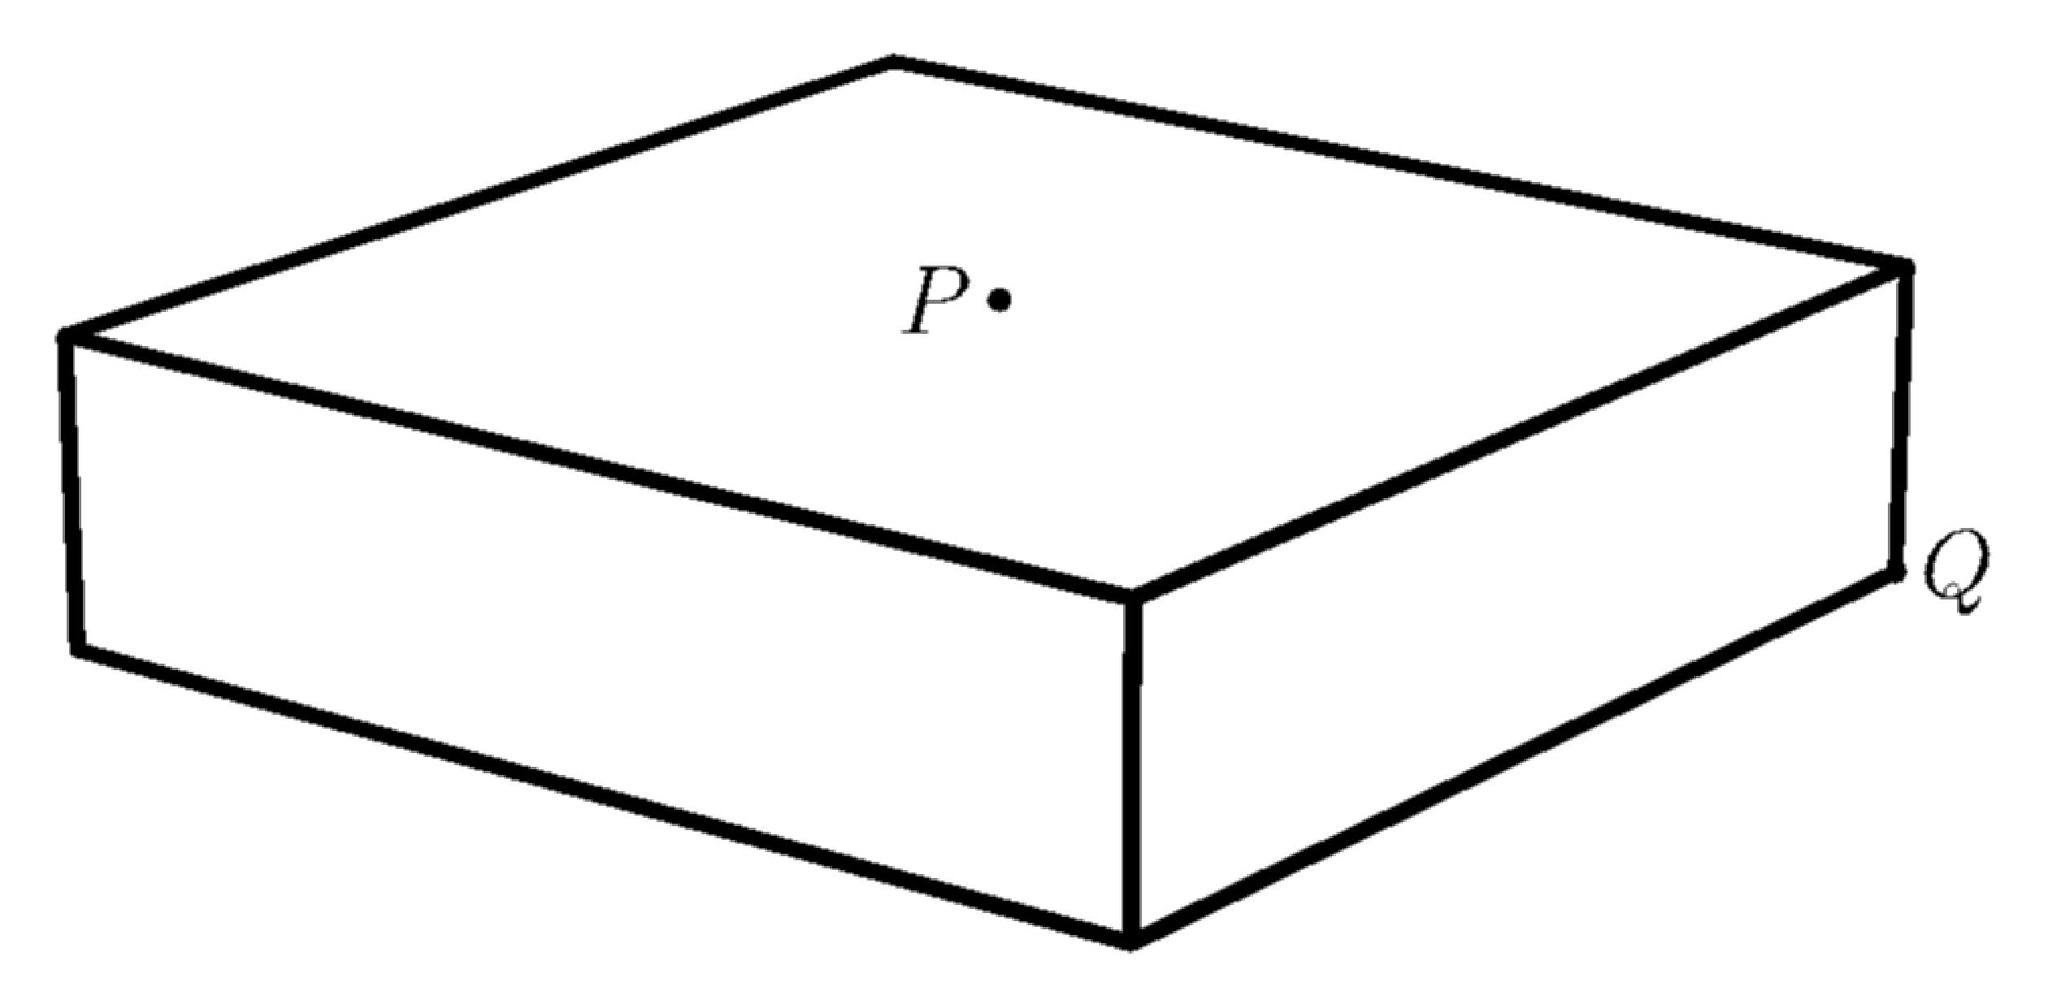If this box were to be filled with water, how would we calculate the volume in cubic centimeters? To calculate the volume of the box if it were filled with water, we use the formula for the volume of a rectangular prism: Volume = length × width × height. Given the box's dimensions are 16 cm by 16 cm by 4 cm, the volume would be 16 × 16 × 4 = 1024 cubic centimeters. This is the amount of water the box could hold. 